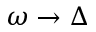<formula> <loc_0><loc_0><loc_500><loc_500>\omega \to \Delta</formula> 